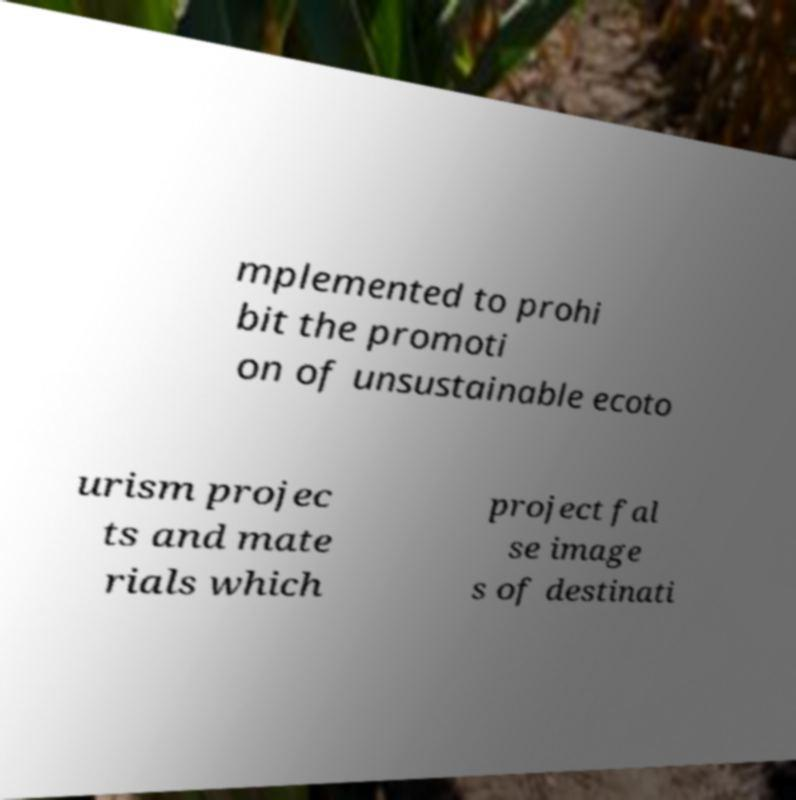Please identify and transcribe the text found in this image. mplemented to prohi bit the promoti on of unsustainable ecoto urism projec ts and mate rials which project fal se image s of destinati 